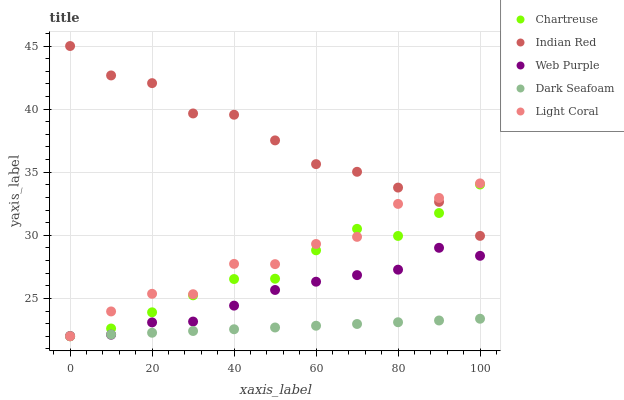Does Dark Seafoam have the minimum area under the curve?
Answer yes or no. Yes. Does Indian Red have the maximum area under the curve?
Answer yes or no. Yes. Does Light Coral have the minimum area under the curve?
Answer yes or no. No. Does Light Coral have the maximum area under the curve?
Answer yes or no. No. Is Dark Seafoam the smoothest?
Answer yes or no. Yes. Is Light Coral the roughest?
Answer yes or no. Yes. Is Chartreuse the smoothest?
Answer yes or no. No. Is Chartreuse the roughest?
Answer yes or no. No. Does Dark Seafoam have the lowest value?
Answer yes or no. Yes. Does Web Purple have the lowest value?
Answer yes or no. No. Does Indian Red have the highest value?
Answer yes or no. Yes. Does Light Coral have the highest value?
Answer yes or no. No. Is Dark Seafoam less than Indian Red?
Answer yes or no. Yes. Is Indian Red greater than Web Purple?
Answer yes or no. Yes. Does Light Coral intersect Web Purple?
Answer yes or no. Yes. Is Light Coral less than Web Purple?
Answer yes or no. No. Is Light Coral greater than Web Purple?
Answer yes or no. No. Does Dark Seafoam intersect Indian Red?
Answer yes or no. No. 